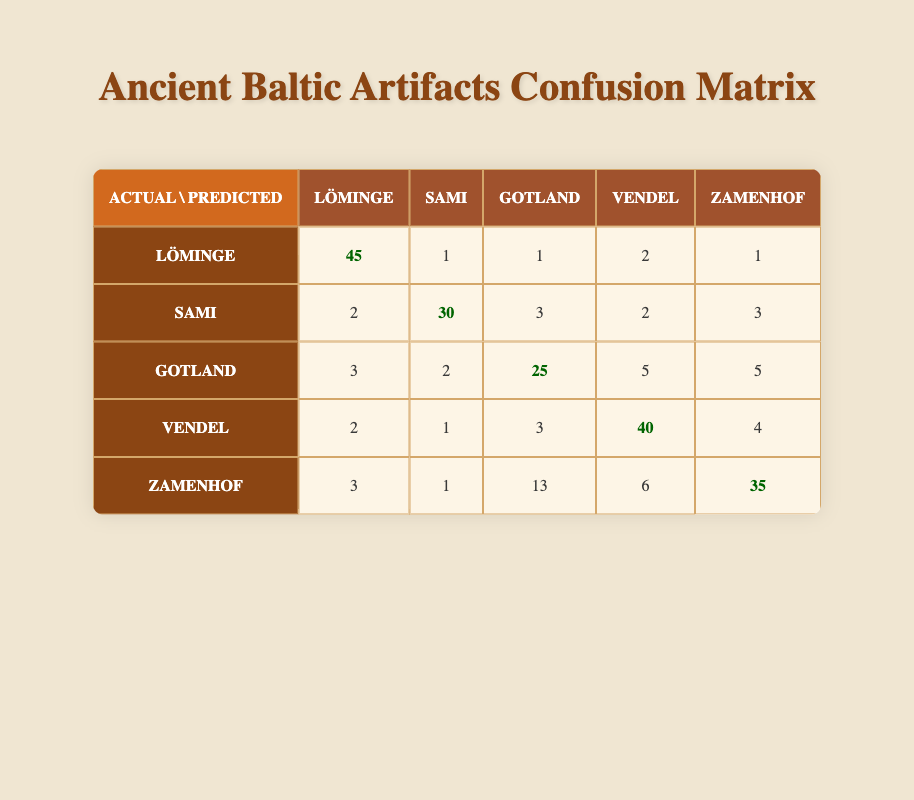What is the total number of Löminge Culture artifacts identified correctly? The table shows that 45 Löminge Culture artifacts were identified correctly.
Answer: 45 How many artifacts were incorrectly identified as Gotland Culture artifacts? According to the table, 15 artifacts were incorrectly identified as Gotland Culture artifacts.
Answer: 15 What is the total number of Sami Culture artifacts identified, both correctly and incorrectly? To find the total for Sami Culture artifacts, we add the correctly identified (30) and incorrectly identified artifacts (10): 30 + 10 = 40.
Answer: 40 Was the number of true positives for the Zamenhof Culture artifacts greater than the identified incorrectly? The table shows that 35 artifacts were identified correctly (true positives) for Zamenhof Culture, while 25 were identified incorrectly. Since 35 is greater than 25, the statement is true.
Answer: Yes What is the difference between the correctly identified Löminge and Vendel Culture artifacts? Löminge Culture artifacts were identified correctly 45 times, while Vendel Culture artifacts were identified correctly 40 times. The difference is 45 - 40 = 5.
Answer: 5 What percentage of the Gotland Culture artifacts were identified correctly? There were 25 correctly identified Gotland Culture artifacts out of the total identified (25 + 15 = 40). To find the percentage: (25/40) * 100 = 62.5%.
Answer: 62.5% What is the average number of artifacts identified correctly across all cultures? The correct identifications are: 45 (Löminge) + 30 (Sami) + 25 (Gotland) + 40 (Vendel) + 35 (Zamenhof) = 205. There are 5 cultures, so the average is 205/5 = 41.
Answer: 41 How many more false positives were there in the Zamenhof Culture compared to the Vendel Culture? The table indicates that Zamenhof had 30 false positives and Vendel had 15. The difference is 30 - 15 = 15.
Answer: 15 What is the total number of artifacts identified incorrectly for all cultures combined? Adding the incorrectly identified for each culture gives: 5 (Löminge) + 10 (Sami) + 15 (Gotland) + 10 (Vendel) + 25 (Zamenhof) = 75.
Answer: 75 